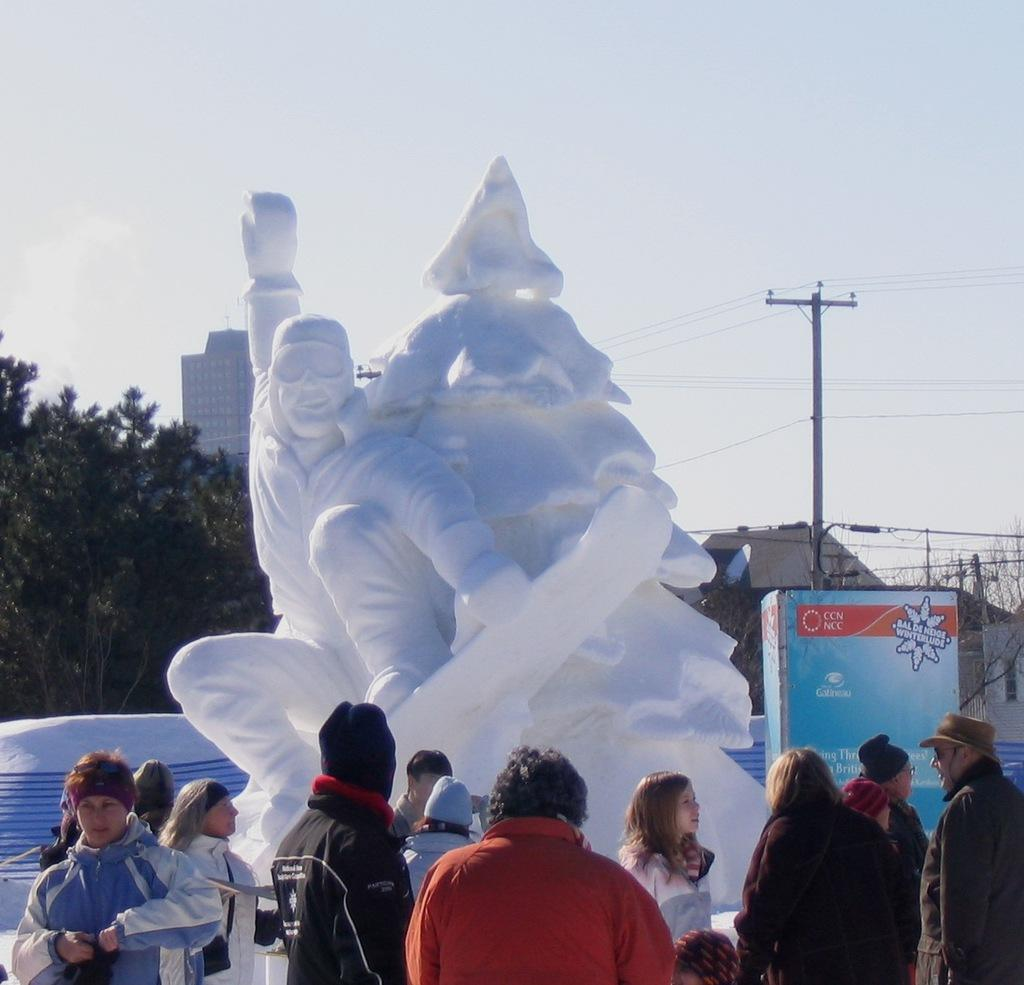What is the main subject in the image? There is a statue in the image. Are there any other subjects or objects in the image? Yes, there are people, trees, a building, and a board in the image. Can you describe the setting of the image? The image features a statue, people, trees, and a building, which suggests an outdoor or public space. What might the board be used for in the image? The board could be used for displaying information, advertisements, or announcements. What type of coat is the porter wearing in the image? There is no porter or coat present in the image. How does the organization of the people in the image contribute to the overall scene? There is no mention of an organization or specific arrangement of people in the image, so this question cannot be answered definitively. 